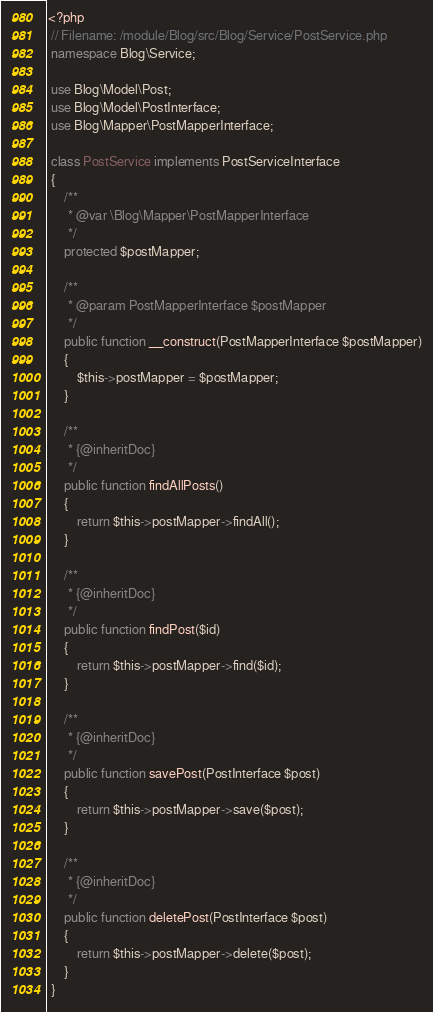Convert code to text. <code><loc_0><loc_0><loc_500><loc_500><_PHP_><?php
 // Filename: /module/Blog/src/Blog/Service/PostService.php
 namespace Blog\Service;

 use Blog\Model\Post;
 use Blog\Model\PostInterface;
 use Blog\Mapper\PostMapperInterface;

 class PostService implements PostServiceInterface
 {
     /**
      * @var \Blog\Mapper\PostMapperInterface
      */
     protected $postMapper;

     /**
      * @param PostMapperInterface $postMapper
      */
     public function __construct(PostMapperInterface $postMapper)
     {
         $this->postMapper = $postMapper;
     }

     /**
      * {@inheritDoc}
      */
     public function findAllPosts()
     {
         return $this->postMapper->findAll();
     }

     /**
      * {@inheritDoc}
      */
     public function findPost($id)
     {
         return $this->postMapper->find($id);
     }
	 
	 /**
      * {@inheritDoc}
      */
     public function savePost(PostInterface $post)
     {
         return $this->postMapper->save($post);
     }
	 
	 /**
      * {@inheritDoc}
      */
     public function deletePost(PostInterface $post)
     {
         return $this->postMapper->delete($post);
     }
 }</code> 